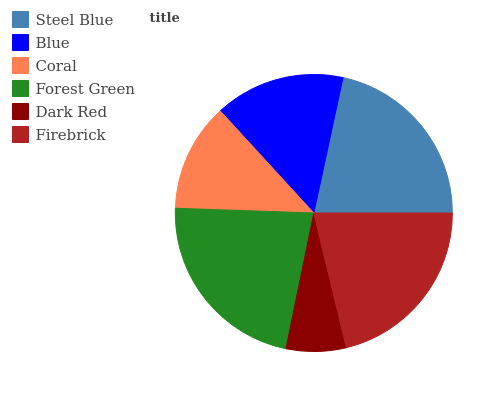Is Dark Red the minimum?
Answer yes or no. Yes. Is Forest Green the maximum?
Answer yes or no. Yes. Is Blue the minimum?
Answer yes or no. No. Is Blue the maximum?
Answer yes or no. No. Is Steel Blue greater than Blue?
Answer yes or no. Yes. Is Blue less than Steel Blue?
Answer yes or no. Yes. Is Blue greater than Steel Blue?
Answer yes or no. No. Is Steel Blue less than Blue?
Answer yes or no. No. Is Firebrick the high median?
Answer yes or no. Yes. Is Blue the low median?
Answer yes or no. Yes. Is Steel Blue the high median?
Answer yes or no. No. Is Steel Blue the low median?
Answer yes or no. No. 